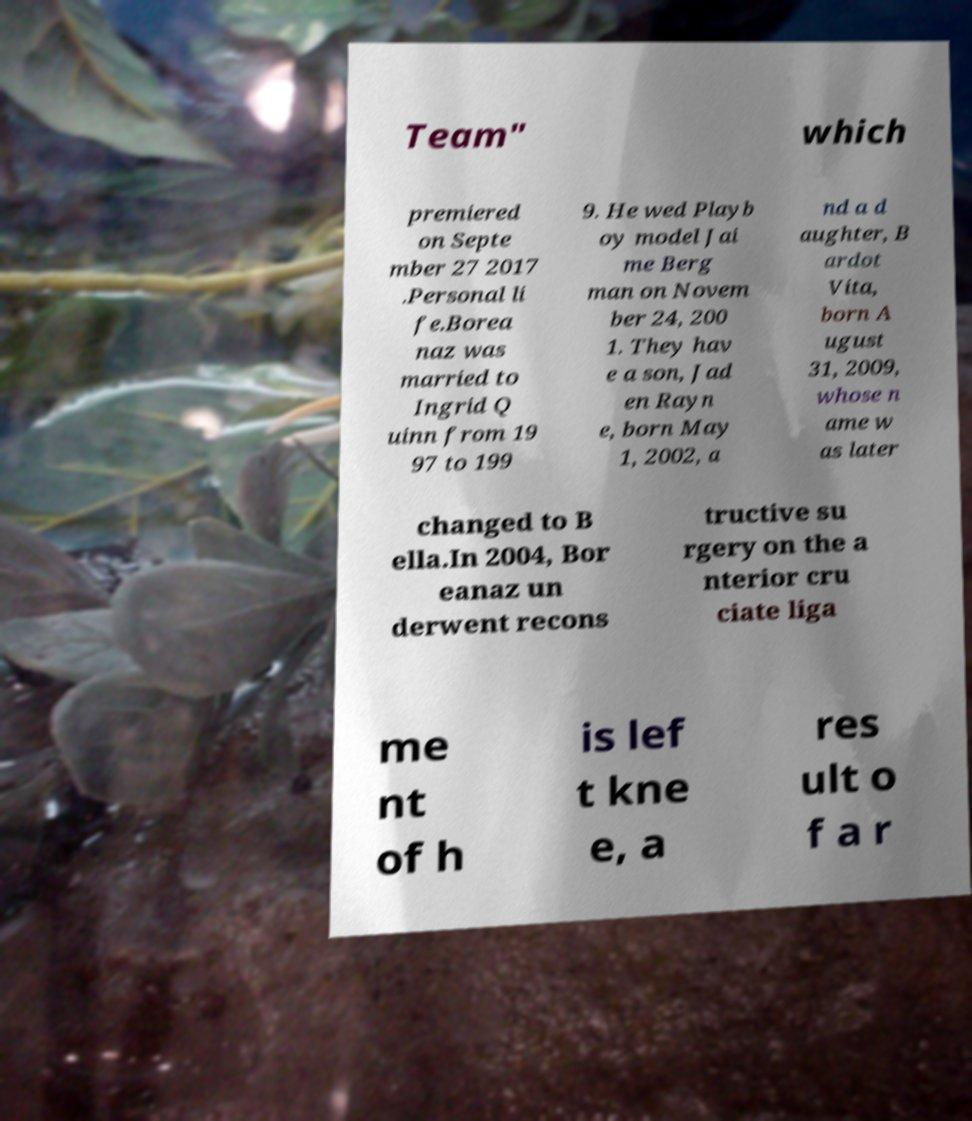Please read and relay the text visible in this image. What does it say? Team" which premiered on Septe mber 27 2017 .Personal li fe.Borea naz was married to Ingrid Q uinn from 19 97 to 199 9. He wed Playb oy model Jai me Berg man on Novem ber 24, 200 1. They hav e a son, Jad en Rayn e, born May 1, 2002, a nd a d aughter, B ardot Vita, born A ugust 31, 2009, whose n ame w as later changed to B ella.In 2004, Bor eanaz un derwent recons tructive su rgery on the a nterior cru ciate liga me nt of h is lef t kne e, a res ult o f a r 